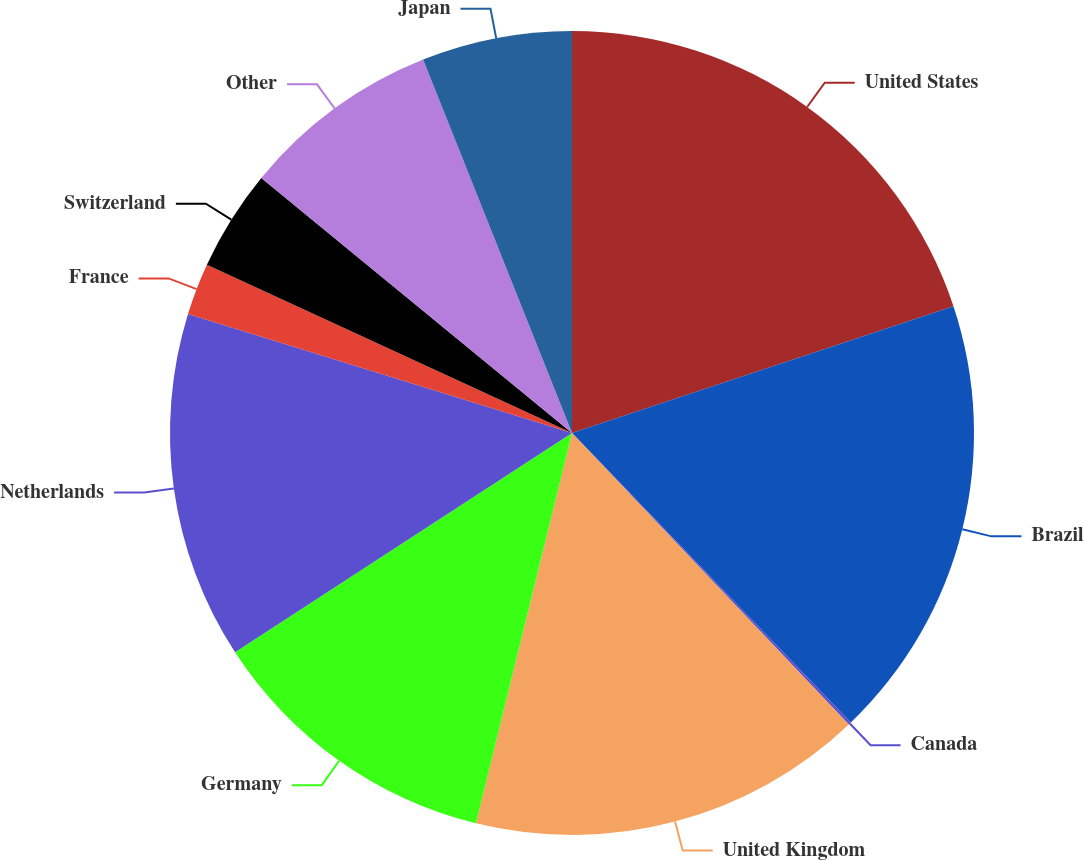<chart> <loc_0><loc_0><loc_500><loc_500><pie_chart><fcel>United States<fcel>Brazil<fcel>Canada<fcel>United Kingdom<fcel>Germany<fcel>Netherlands<fcel>France<fcel>Switzerland<fcel>Other<fcel>Japan<nl><fcel>19.89%<fcel>17.91%<fcel>0.11%<fcel>15.93%<fcel>11.98%<fcel>13.96%<fcel>2.09%<fcel>4.07%<fcel>8.02%<fcel>6.04%<nl></chart> 